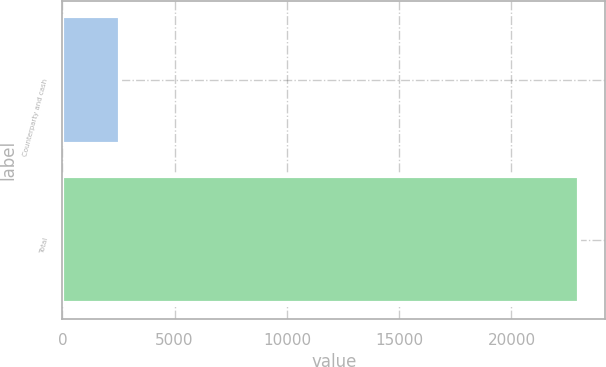<chart> <loc_0><loc_0><loc_500><loc_500><bar_chart><fcel>Counterparty and cash<fcel>Total<nl><fcel>2559<fcel>23029<nl></chart> 